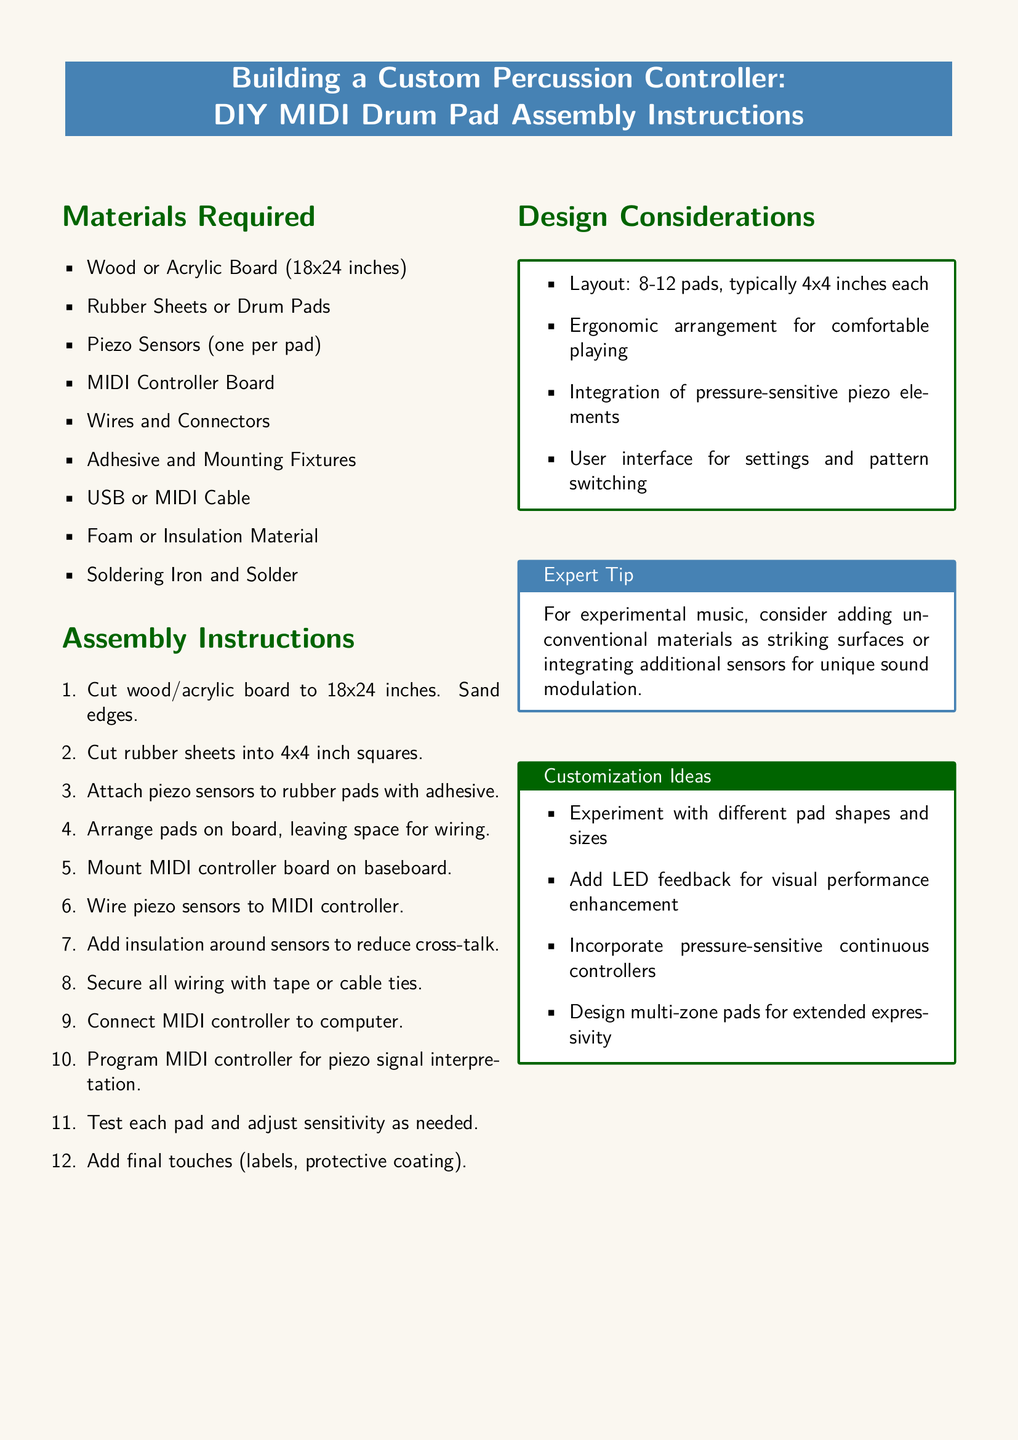what is the size of the main board? The document specifies that the board should be cut to the dimensions of 18x24 inches.
Answer: 18x24 inches how many piezo sensors are required? The document states that one piezo sensor is needed for each pad, but it does not specify the number of pads directly. Using design considerations, if there are 8-12 pads, you would need 8-12 piezo sensors.
Answer: 8-12 what is the suggested shape for the rubber pads? The assembly instructions recommend cutting rubber sheets into 4x4 inch squares for the pads.
Answer: 4x4 inches what should be added around the sensors? The document mentions adding insulation around the sensors to reduce cross-talk.
Answer: Insulation what is an expert tip for experimental music? The document suggests considering adding unconventional materials as striking surfaces or integrating additional sensors for unique sound modulation.
Answer: Unconventional materials how many assembly steps are listed? The assembly instructions outline a total of 12 steps for building the percussion controller.
Answer: 12 what type of cable is required to connect the MIDI controller? The document specifies that either a USB or MIDI cable is needed for the connection.
Answer: USB or MIDI Cable what is one design consideration mentioned? The document lists ergonomic arrangement as a key consideration when designing the percussion controller.
Answer: Ergonomic arrangement which tool is required for securing wiring? According to the assembly instructions, tape or cable ties should be used to secure all wiring.
Answer: Tape or cable ties 